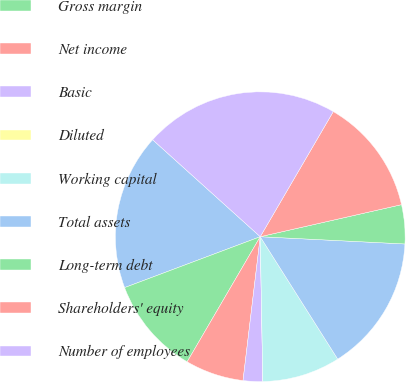Convert chart to OTSL. <chart><loc_0><loc_0><loc_500><loc_500><pie_chart><fcel>Revenue net<fcel>Gross margin<fcel>Net income<fcel>Basic<fcel>Diluted<fcel>Working capital<fcel>Total assets<fcel>Long-term debt<fcel>Shareholders' equity<fcel>Number of employees<nl><fcel>17.39%<fcel>10.87%<fcel>6.52%<fcel>2.18%<fcel>0.0%<fcel>8.7%<fcel>15.22%<fcel>4.35%<fcel>13.04%<fcel>21.74%<nl></chart> 